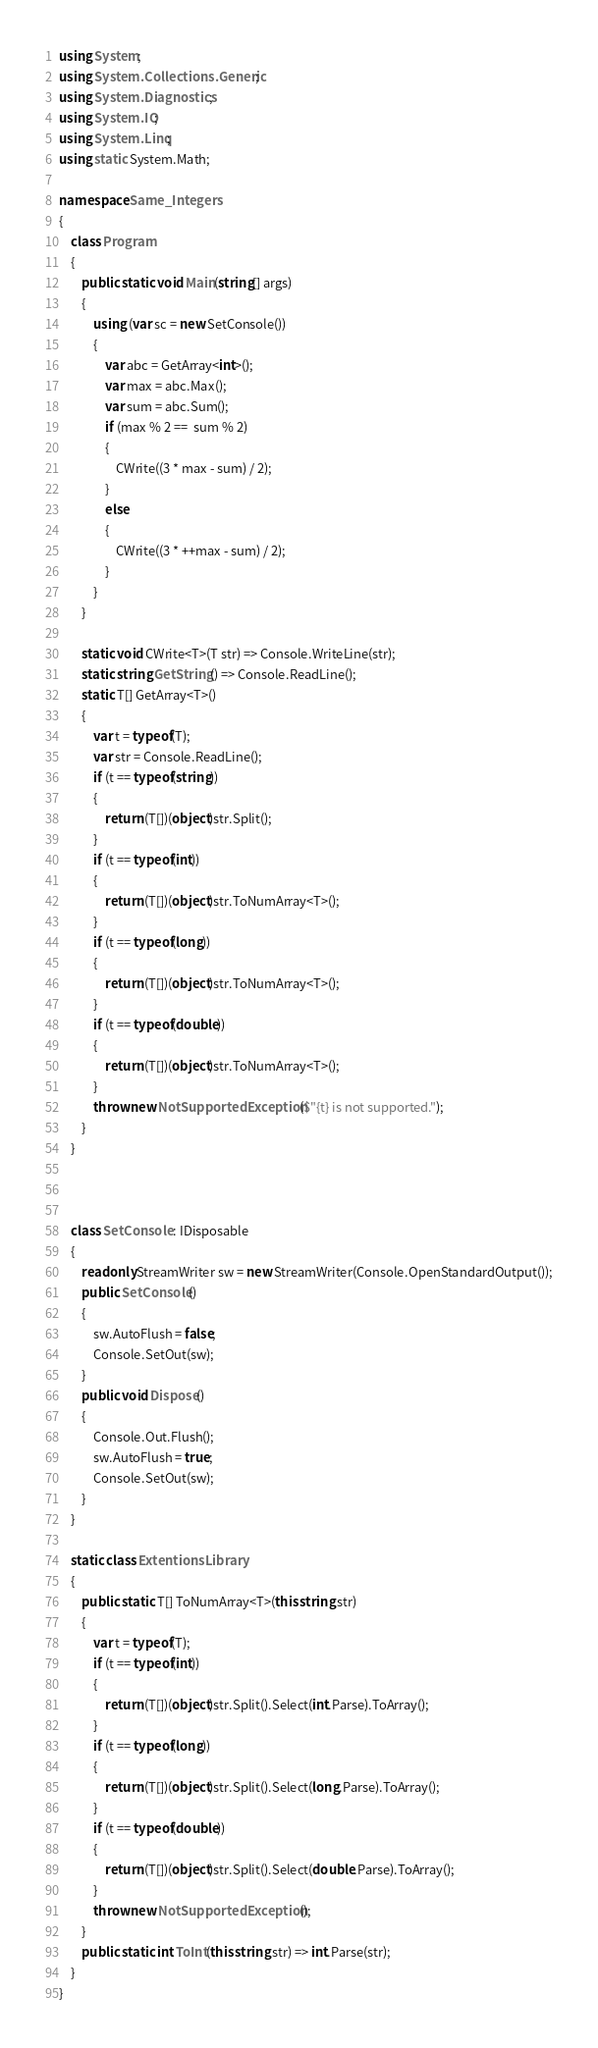<code> <loc_0><loc_0><loc_500><loc_500><_C#_>using System;
using System.Collections.Generic;
using System.Diagnostics;
using System.IO;
using System.Linq;
using static System.Math;

namespace Same_Integers
{
    class Program
    {
        public static void Main(string[] args)
        {
            using (var sc = new SetConsole())
            {
                var abc = GetArray<int>();
                var max = abc.Max();
                var sum = abc.Sum();
                if (max % 2 ==  sum % 2)
                {
                    CWrite((3 * max - sum) / 2);
                }
                else
                {
                    CWrite((3 * ++max - sum) / 2);
                }
            }
        }

        static void CWrite<T>(T str) => Console.WriteLine(str);
        static string GetString() => Console.ReadLine();
        static T[] GetArray<T>()
        {
            var t = typeof(T);
            var str = Console.ReadLine();
            if (t == typeof(string))
            {
                return (T[])(object)str.Split();
            }
            if (t == typeof(int))
            {
                return (T[])(object)str.ToNumArray<T>();
            }
            if (t == typeof(long))
            {
                return (T[])(object)str.ToNumArray<T>();
            }
            if (t == typeof(double))
            {
                return (T[])(object)str.ToNumArray<T>();
            }
            throw new NotSupportedException($"{t} is not supported.");
        }
    }



    class SetConsole : IDisposable
    {
        readonly StreamWriter sw = new StreamWriter(Console.OpenStandardOutput());
        public SetConsole()
        {
            sw.AutoFlush = false;
            Console.SetOut(sw);
        }
        public void Dispose()
        {
            Console.Out.Flush();
            sw.AutoFlush = true;
            Console.SetOut(sw);
        }
    }

    static class ExtentionsLibrary
    {
        public static T[] ToNumArray<T>(this string str)
        {
            var t = typeof(T);
            if (t == typeof(int))
            {
                return (T[])(object)str.Split().Select(int.Parse).ToArray();
            }
            if (t == typeof(long))
            {
                return (T[])(object)str.Split().Select(long.Parse).ToArray();
            }
            if (t == typeof(double))
            {
                return (T[])(object)str.Split().Select(double.Parse).ToArray();
            }
            throw new NotSupportedException();
        }
        public static int ToInt(this string str) => int.Parse(str);
    }
}
</code> 